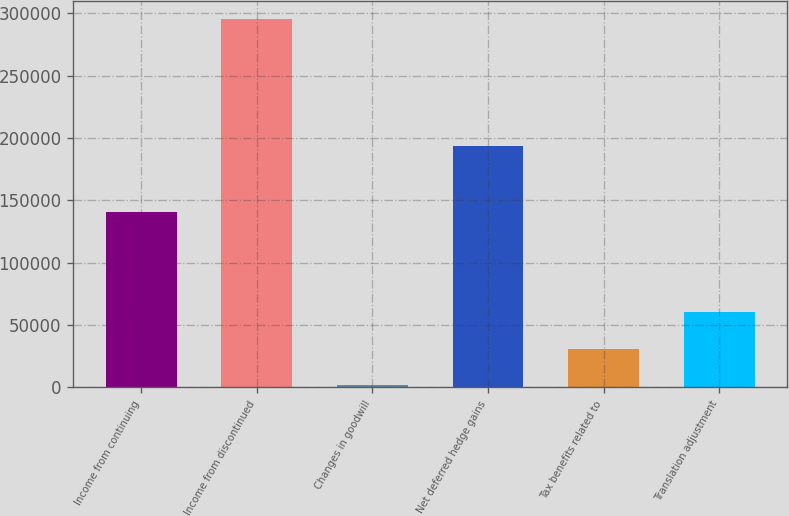<chart> <loc_0><loc_0><loc_500><loc_500><bar_chart><fcel>Income from continuing<fcel>Income from discontinued<fcel>Changes in goodwill<fcel>Net deferred hedge gains<fcel>Tax benefits related to<fcel>Translation adjustment<nl><fcel>141021<fcel>295501<fcel>1742<fcel>193719<fcel>31117.9<fcel>60493.8<nl></chart> 